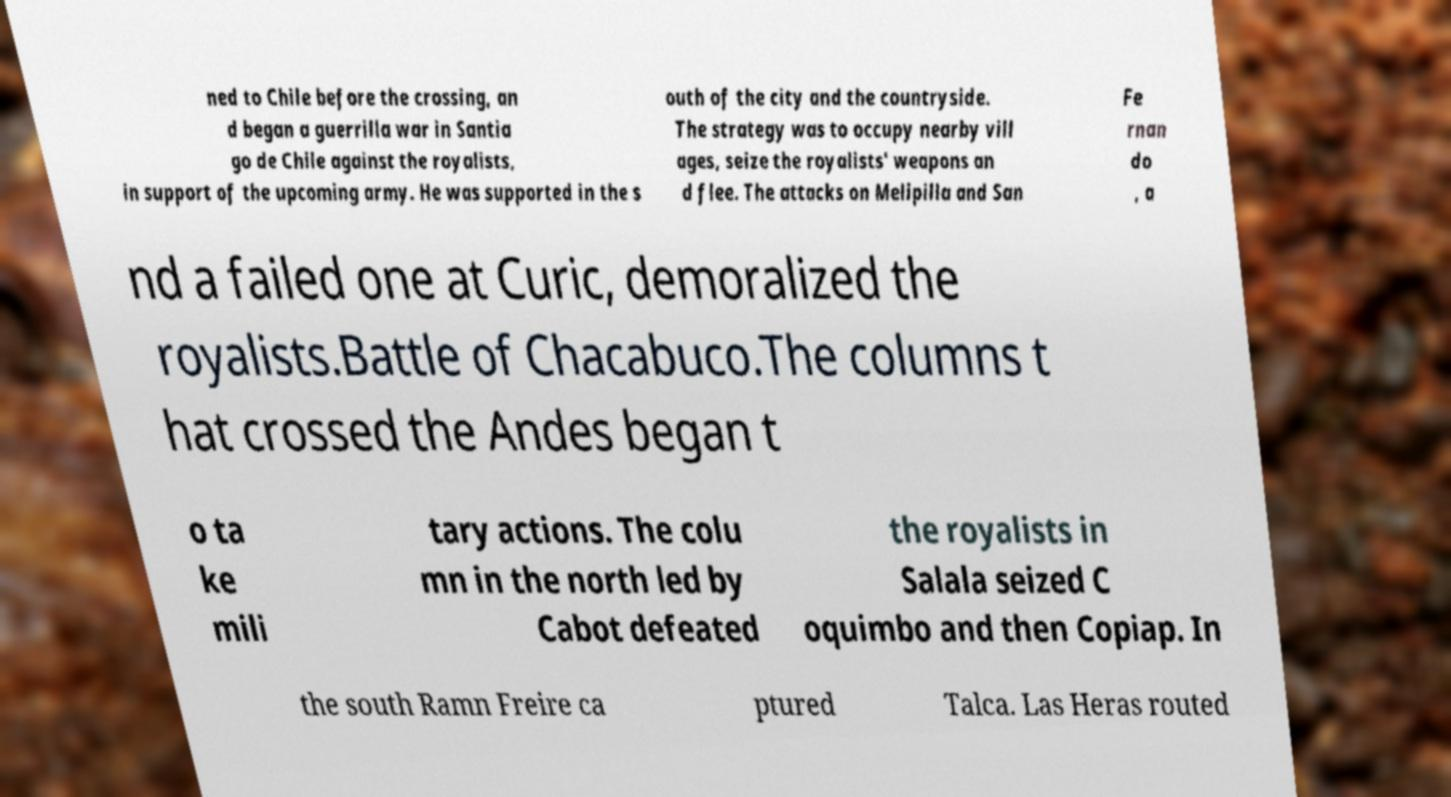I need the written content from this picture converted into text. Can you do that? ned to Chile before the crossing, an d began a guerrilla war in Santia go de Chile against the royalists, in support of the upcoming army. He was supported in the s outh of the city and the countryside. The strategy was to occupy nearby vill ages, seize the royalists' weapons an d flee. The attacks on Melipilla and San Fe rnan do , a nd a failed one at Curic, demoralized the royalists.Battle of Chacabuco.The columns t hat crossed the Andes began t o ta ke mili tary actions. The colu mn in the north led by Cabot defeated the royalists in Salala seized C oquimbo and then Copiap. In the south Ramn Freire ca ptured Talca. Las Heras routed 